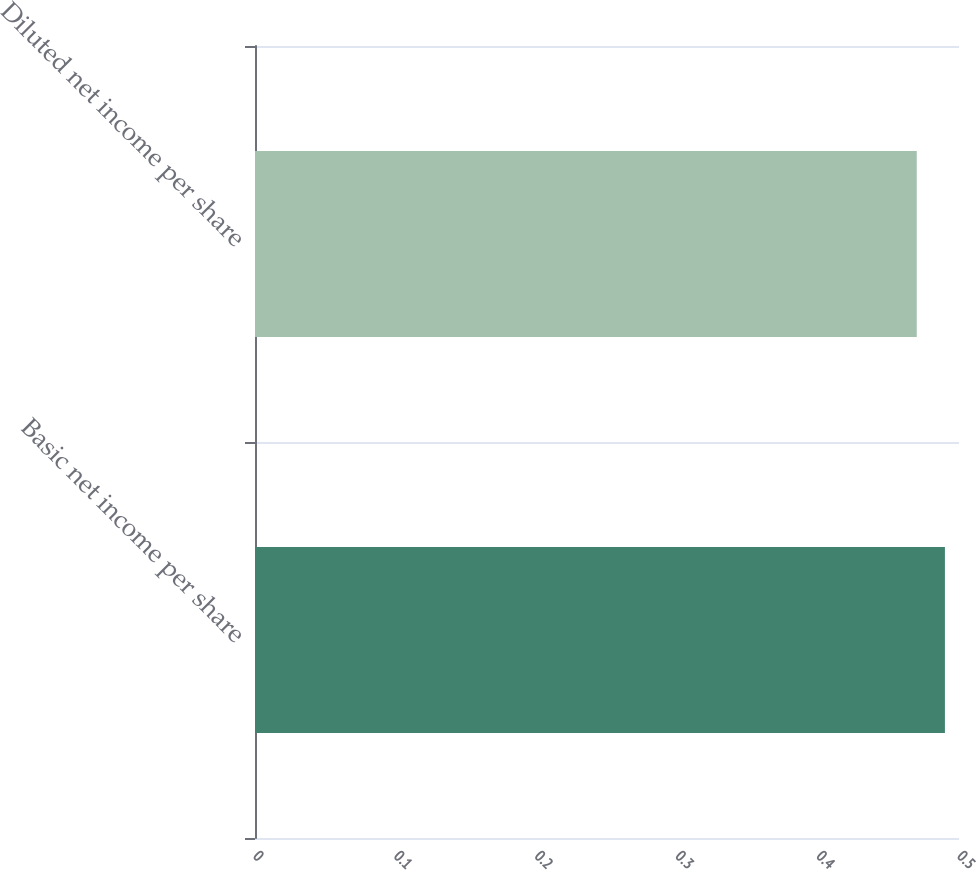<chart> <loc_0><loc_0><loc_500><loc_500><bar_chart><fcel>Basic net income per share<fcel>Diluted net income per share<nl><fcel>0.49<fcel>0.47<nl></chart> 